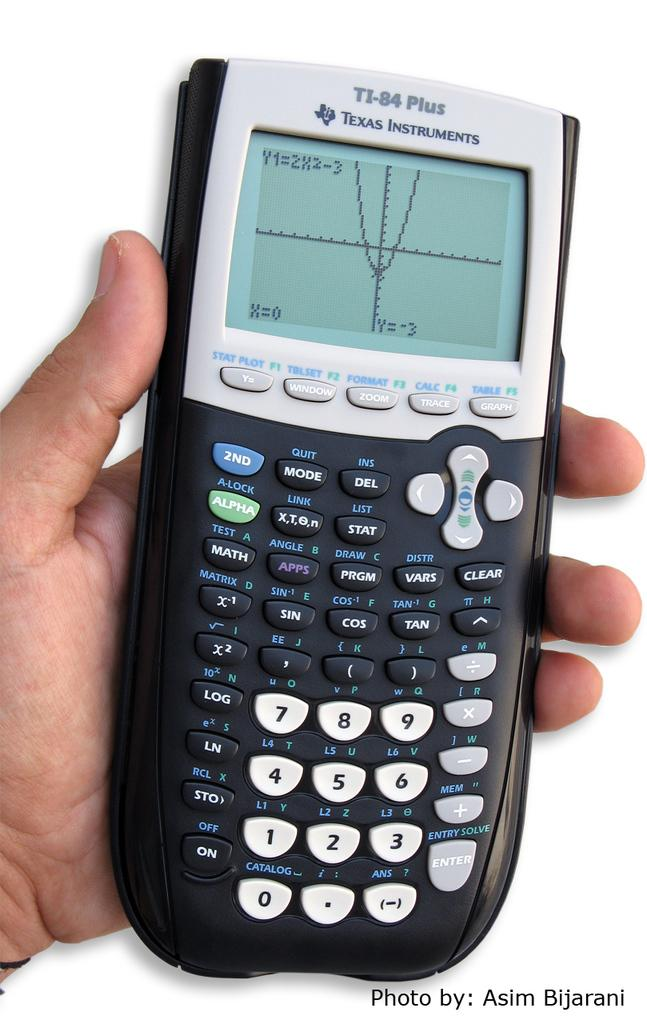Provide a one-sentence caption for the provided image. A TI-84 plus calculator that was taken by Asim. 